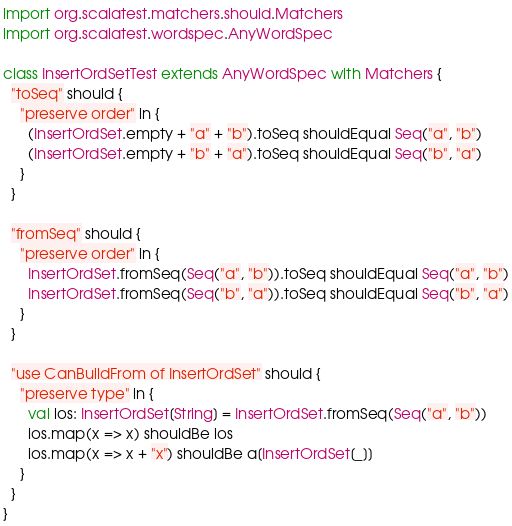<code> <loc_0><loc_0><loc_500><loc_500><_Scala_>
import org.scalatest.matchers.should.Matchers
import org.scalatest.wordspec.AnyWordSpec

class InsertOrdSetTest extends AnyWordSpec with Matchers {
  "toSeq" should {
    "preserve order" in {
      (InsertOrdSet.empty + "a" + "b").toSeq shouldEqual Seq("a", "b")
      (InsertOrdSet.empty + "b" + "a").toSeq shouldEqual Seq("b", "a")
    }
  }

  "fromSeq" should {
    "preserve order" in {
      InsertOrdSet.fromSeq(Seq("a", "b")).toSeq shouldEqual Seq("a", "b")
      InsertOrdSet.fromSeq(Seq("b", "a")).toSeq shouldEqual Seq("b", "a")
    }
  }

  "use CanBuildFrom of InsertOrdSet" should {
    "preserve type" in {
      val ios: InsertOrdSet[String] = InsertOrdSet.fromSeq(Seq("a", "b"))
      ios.map(x => x) shouldBe ios
      ios.map(x => x + "x") shouldBe a[InsertOrdSet[_]]
    }
  }
}
</code> 